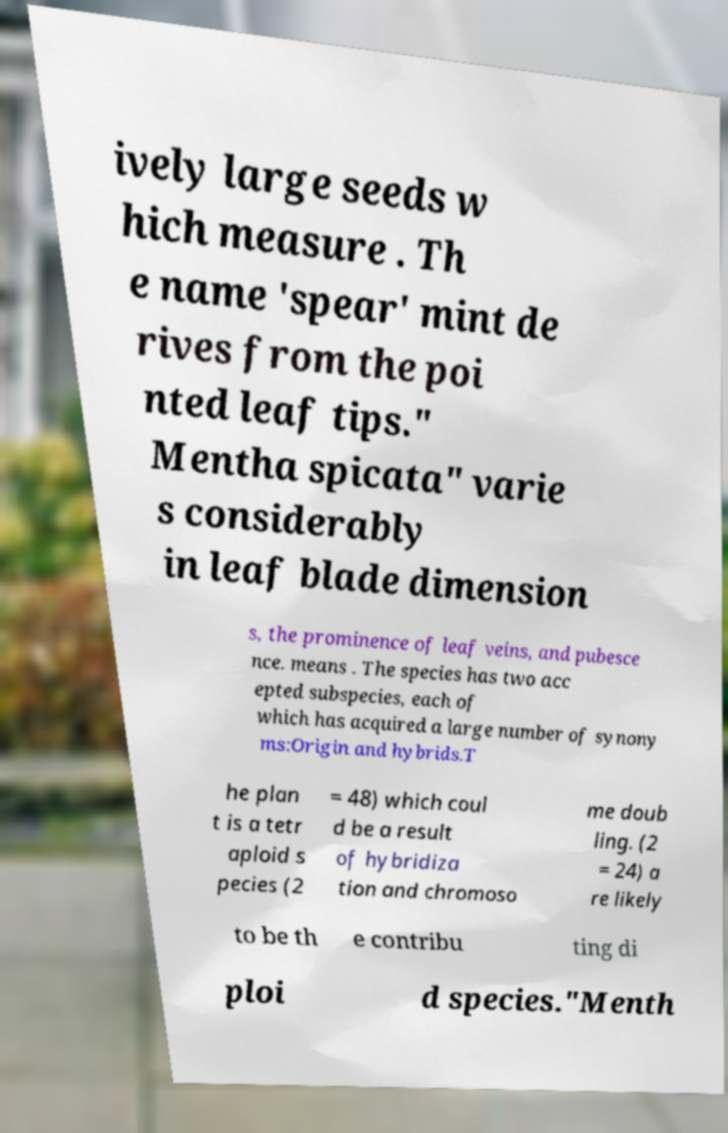Could you assist in decoding the text presented in this image and type it out clearly? ively large seeds w hich measure . Th e name 'spear' mint de rives from the poi nted leaf tips." Mentha spicata" varie s considerably in leaf blade dimension s, the prominence of leaf veins, and pubesce nce. means . The species has two acc epted subspecies, each of which has acquired a large number of synony ms:Origin and hybrids.T he plan t is a tetr aploid s pecies (2 = 48) which coul d be a result of hybridiza tion and chromoso me doub ling. (2 = 24) a re likely to be th e contribu ting di ploi d species."Menth 